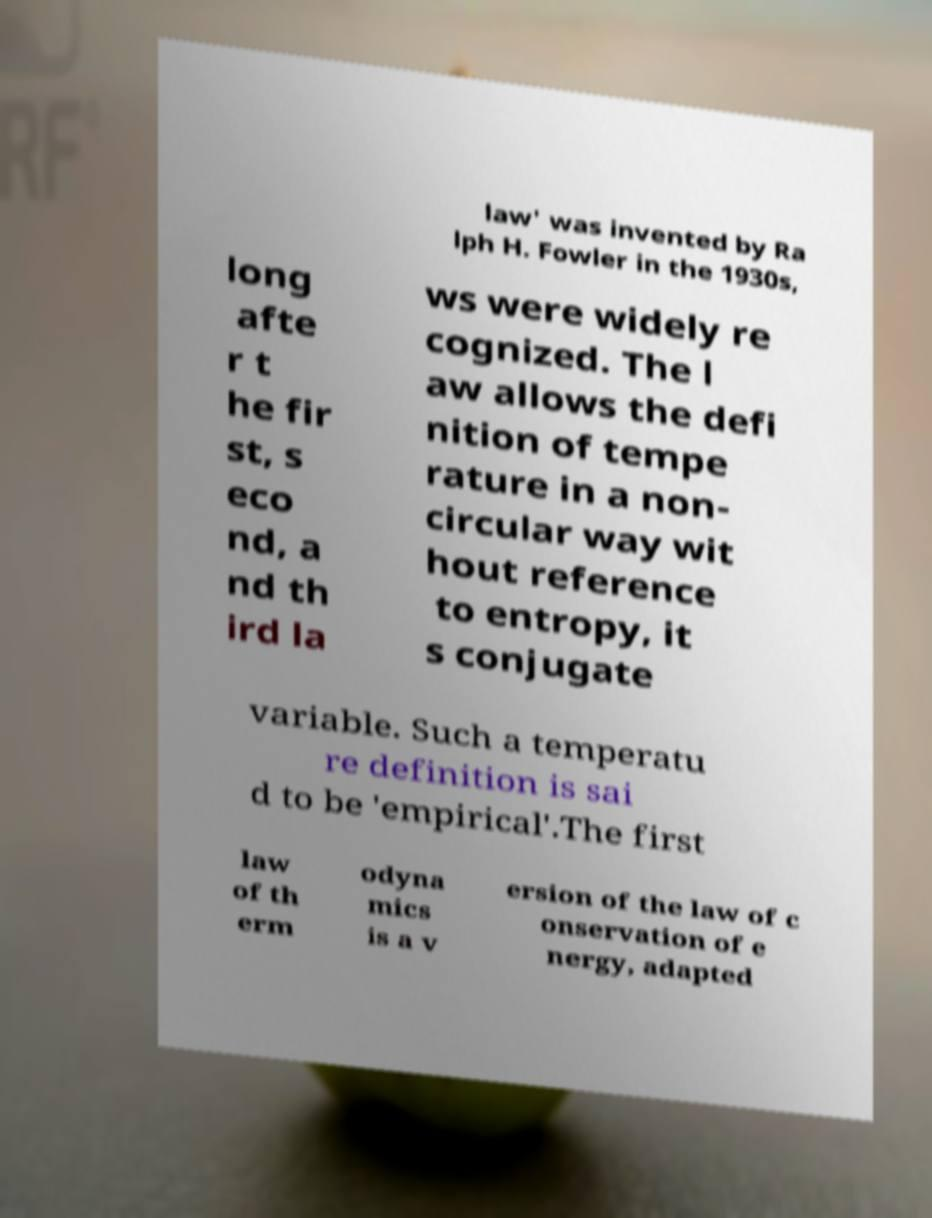Can you read and provide the text displayed in the image?This photo seems to have some interesting text. Can you extract and type it out for me? law' was invented by Ra lph H. Fowler in the 1930s, long afte r t he fir st, s eco nd, a nd th ird la ws were widely re cognized. The l aw allows the defi nition of tempe rature in a non- circular way wit hout reference to entropy, it s conjugate variable. Such a temperatu re definition is sai d to be 'empirical'.The first law of th erm odyna mics is a v ersion of the law of c onservation of e nergy, adapted 